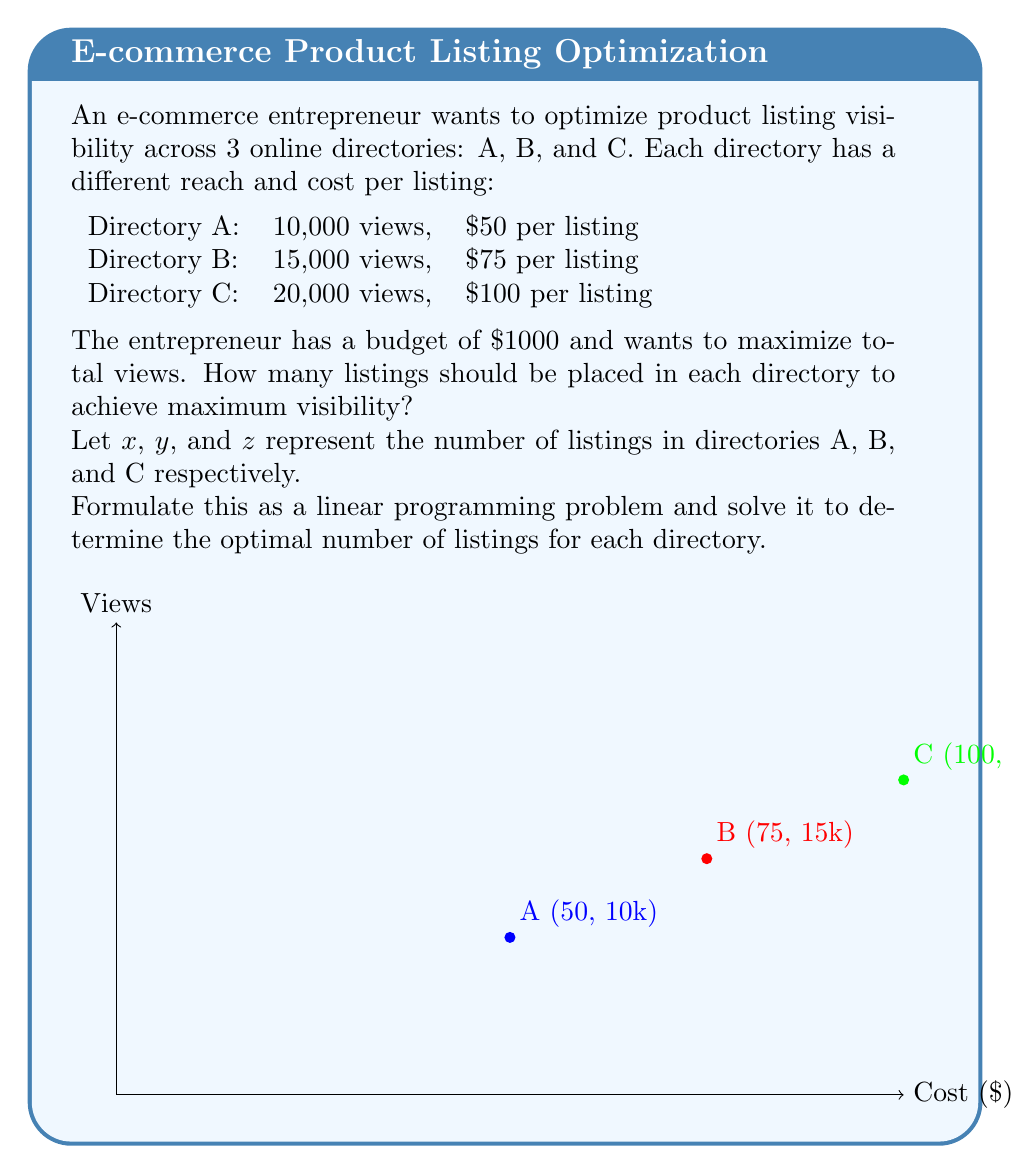Can you solve this math problem? Let's solve this step-by-step using linear programming:

1) Objective function: Maximize total views
   $$ \text{Maximize } Z = 10000x + 15000y + 20000z $$

2) Constraints:
   Budget constraint: $$ 50x + 75y + 100z \leq 1000 $$
   Non-negativity: $$ x, y, z \geq 0 $$

3) To solve, we'll use the simplex method. First, let's convert the inequality to an equation by introducing a slack variable $s$:
   $$ 50x + 75y + 100z + s = 1000 $$

4) Initial tableau:
   $$
   \begin{array}{c|cccc|c}
               & x    & y    & z    & s    & \text{RHS} \\
   \hline
   Z           & -10000 & -15000 & -20000 & 0    & 0 \\
   s           & 50   & 75   & 100  & 1    & 1000 \\
   \hline
   \text{Ratio} & 20   & 13.33 & 10   & -    & - \\
   \end{array}
   $$

5) The most negative coefficient in the Z row is -20000, so we choose the z column as our pivot column. The smallest ratio is 10, corresponding to the z row, so this is our pivot row.

6) After pivoting:
   $$
   \begin{array}{c|cccc|c}
               & x    & y    & z    & s    & \text{RHS} \\
   \hline
   Z           & 5000 & 5000 & 0    & 200  & 20000 \\
   z           & 0.5  & 0.75 & 1    & 0.01 & 10 \\
   \end{array}
   $$

7) All coefficients in the Z row are non-negative, so we've reached the optimal solution.

8) Reading the solution:
   $z = 10$ (listings in directory C)
   $x = y = 0$ (no listings in directories A and B)

9) Checking the budget:
   $100 * 10 = $1000, which matches our budget constraint.

10) Total views: $20000 * 10 = 200,000$
Answer: 10 listings in directory C, 0 in A and B 